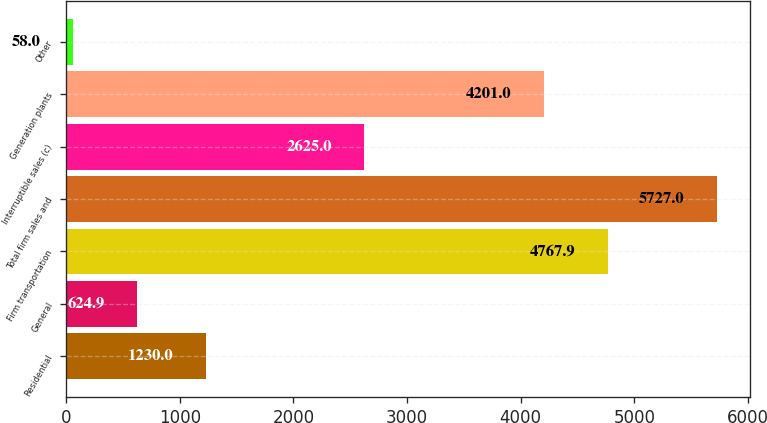Convert chart. <chart><loc_0><loc_0><loc_500><loc_500><bar_chart><fcel>Residential<fcel>General<fcel>Firm transportation<fcel>Total firm sales and<fcel>Interruptible sales (c)<fcel>Generation plants<fcel>Other<nl><fcel>1230<fcel>624.9<fcel>4767.9<fcel>5727<fcel>2625<fcel>4201<fcel>58<nl></chart> 